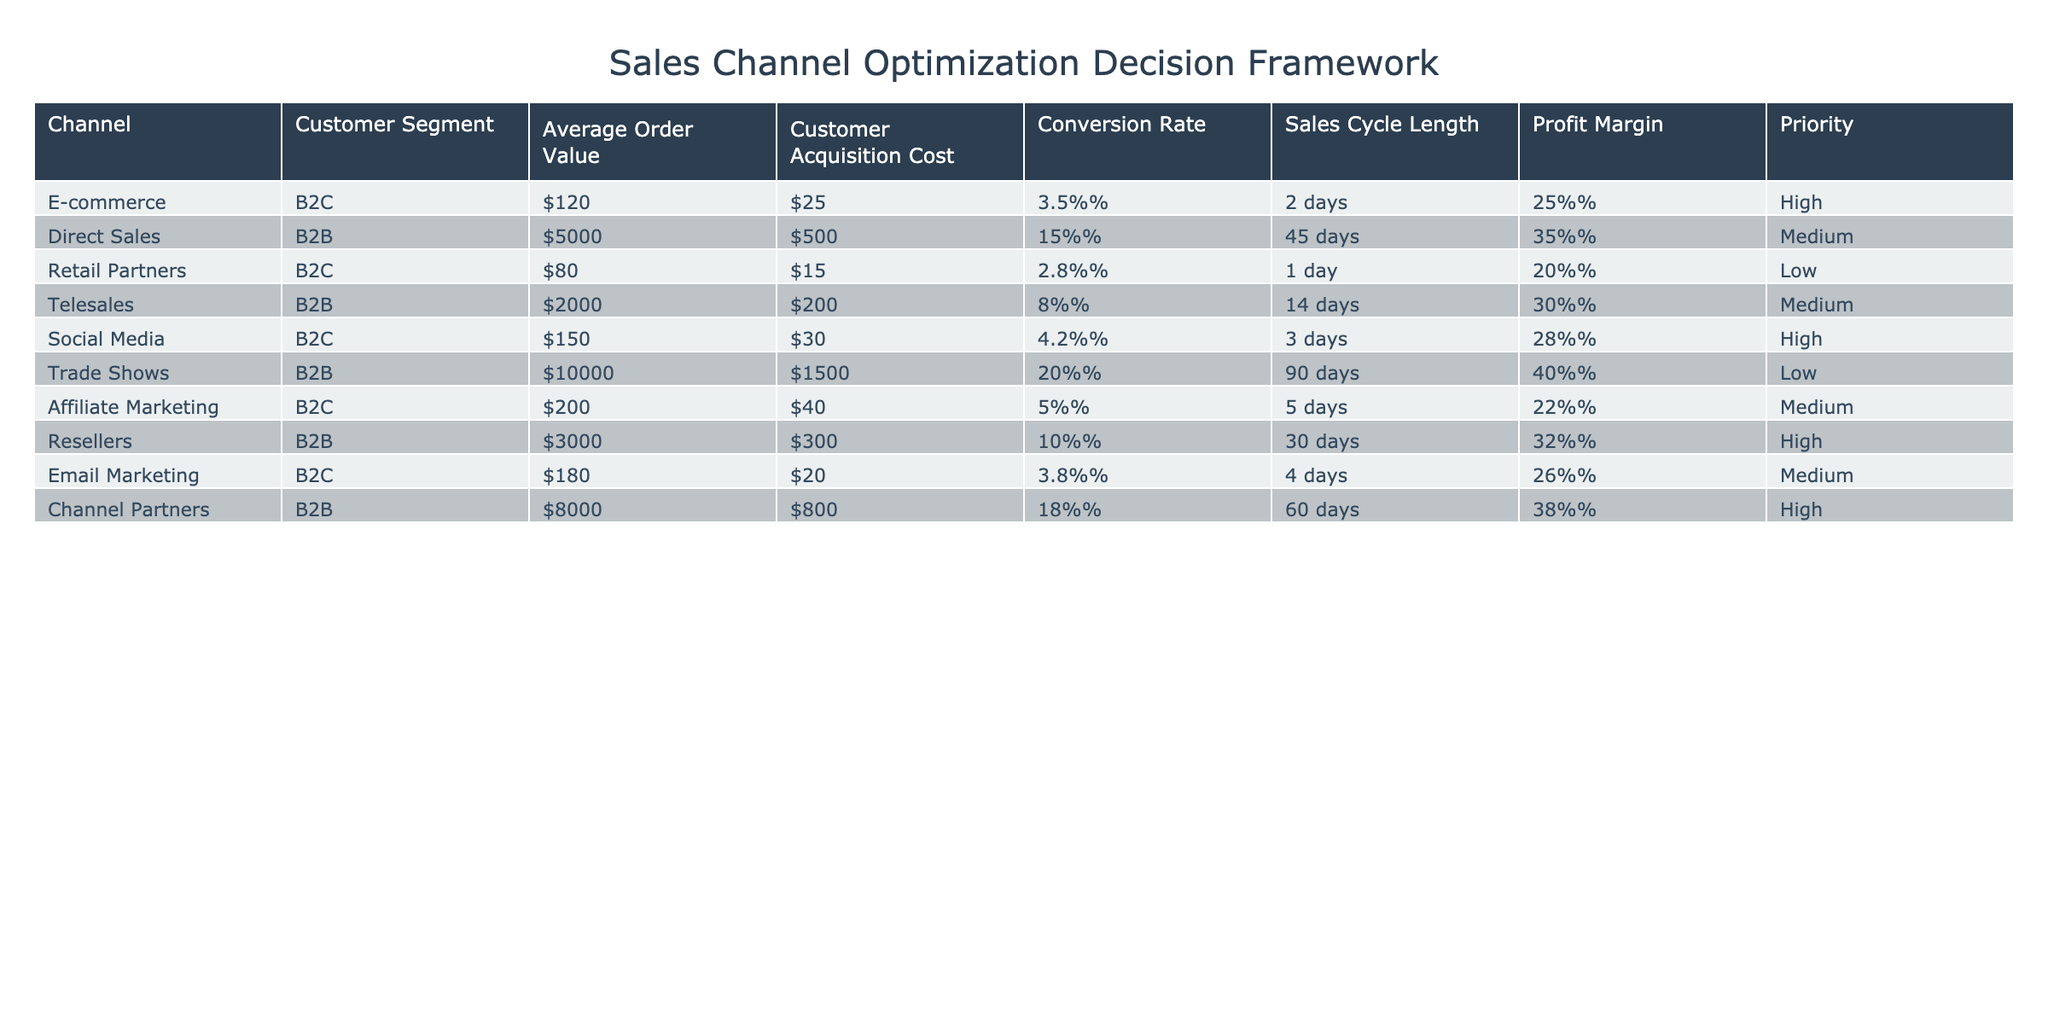What is the Average Order Value for the E-commerce channel? The Average Order Value for the E-commerce channel is specifically stated in the table. We look for the row related to the E-commerce channel and find the corresponding value.
Answer: $120 Which sales channel has the highest Profit Margin? To identify the highest Profit Margin, we compare the Profit Margin values across all channels. The highest value is found under the Trade Shows channel at 40%.
Answer: Trade Shows Is the Customer Acquisition Cost for Direct Sales greater than $400? We examine the Customer Acquisition Cost for Direct Sales, which is indicated in the table as $500. Since $500 is greater than $400, the statement is true.
Answer: Yes What is the total Average Order Value for all B2B channels? First, we identify the B2B channels from the table: Direct Sales, Telesales, Trade Shows, and Channel Partners. Their Average Order Values are $5000, $2000, $10000, and $8000, respectively. We sum these values: 5000 + 2000 + 10000 + 8000 = 25000.
Answer: $25000 Which Customer Segment has the lowest Conversion Rate and what is that rate? We check the Conversion Rates for each Customer Segment in the table. Retail Partners with a B2C segment has a Conversion Rate of 2.8%, which is the lowest.
Answer: Retail Partners, 2.8% How do the Profit Margins of B2C and B2B channels compare? We look at the Profit Margins for B2C channels: E-commerce (25%), Retail Partners (20%), Social Media (28%), Affiliate Marketing (22%), and Email Marketing (26%). Total average for B2C is (25+20+28+22+26) / 5 = 24.2%. For B2B: Direct Sales (35%), Telesales (30%), Trade Shows (40%), Resellers (32%), and Channel Partners (38%). Total average for B2B is (35+30+40+32+38) / 5 = 35%. B2B has a higher average margin.
Answer: B2B has a higher average Profit Margin Are there any channels with High priority that target B2B customers? We check the Priority column for B2B channels. The Direct Sales, Telesales, and Channel Partners have Medium or Low priority. However, no B2B channels are marked as High priority.
Answer: No What is the average Sales Cycle Length for B2C channels? We identify the Sales Cycle Lengths for B2C channels: E-commerce (2 days), Retail Partners (1 day), Social Media (3 days), Affiliate Marketing (5 days), and Email Marketing (4 days). The total is 2 + 1 + 3 + 5 + 4 = 15 days, and the average is 15 / 5 = 3 days.
Answer: 3 days 